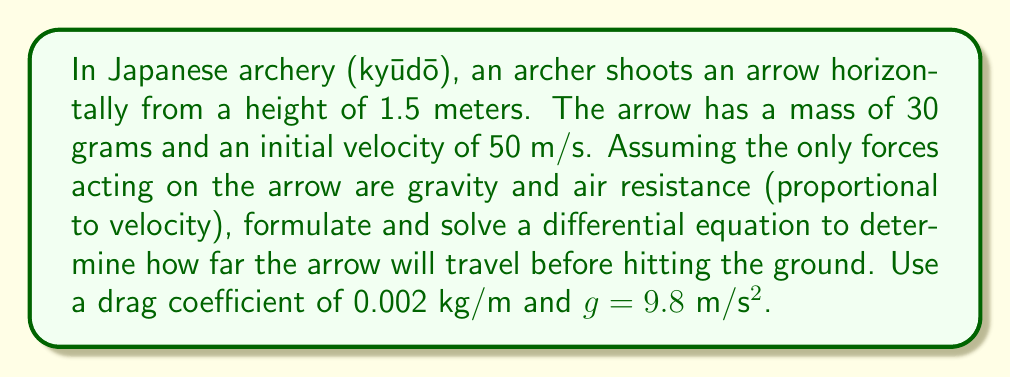Can you solve this math problem? To solve this problem, we need to consider the horizontal and vertical motions separately.

1) Horizontal motion:
The differential equation for horizontal motion is:

$$m\frac{d^2x}{dt^2} = -kv_x$$

Where $m$ is mass, $k$ is the drag coefficient, and $v_x$ is horizontal velocity.

Solving this equation:

$$\frac{dv_x}{dt} = -\frac{k}{m}v_x$$
$$v_x = v_0e^{-\frac{k}{m}t}$$
$$x = \frac{mv_0}{k}(1-e^{-\frac{k}{m}t})$$

2) Vertical motion:
The differential equation for vertical motion is:

$$m\frac{d^2y}{dt^2} = -mg - kv_y$$

Where $g$ is acceleration due to gravity and $v_y$ is vertical velocity.

Solving this:

$$\frac{dv_y}{dt} = -g - \frac{k}{m}v_y$$
$$v_y = -\frac{mg}{k}(1-e^{-\frac{k}{m}t})$$
$$y = 1.5 - \frac{mg}{k}t + \frac{m^2g}{k^2}(1-e^{-\frac{k}{m}t})$$

3) To find when the arrow hits the ground, set $y = 0$ and solve for $t$:

$$0 = 1.5 - \frac{mg}{k}t + \frac{m^2g}{k^2}(1-e^{-\frac{k}{m}t})$$

This equation can't be solved analytically, so we need to use numerical methods.

4) Using the given values:
$m = 0.03$ kg
$k = 0.002$ kg/m
$g = 9.8$ m/s²
$v_0 = 50$ m/s

Solving numerically, we get $t \approx 0.5563$ seconds.

5) Plugging this time back into the equation for $x$:

$$x = \frac{0.03 \cdot 50}{0.002}(1-e^{-\frac{0.002}{0.03}\cdot 0.5563}) \approx 27.62$$

Therefore, the arrow will travel approximately 27.62 meters before hitting the ground.
Answer: The arrow will travel approximately 27.62 meters before hitting the ground. 